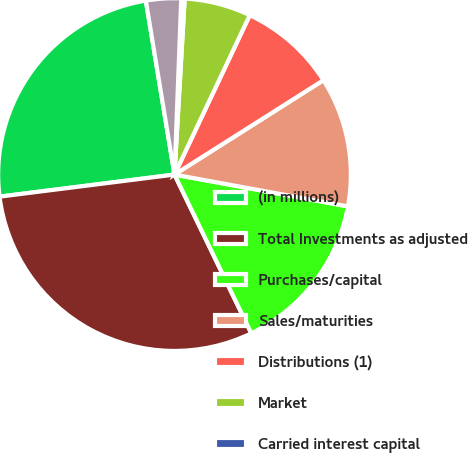<chart> <loc_0><loc_0><loc_500><loc_500><pie_chart><fcel>(in millions)<fcel>Total Investments as adjusted<fcel>Purchases/capital<fcel>Sales/maturities<fcel>Distributions (1)<fcel>Market<fcel>Carried interest capital<fcel>Other<nl><fcel>24.4%<fcel>30.18%<fcel>14.94%<fcel>11.88%<fcel>8.99%<fcel>6.1%<fcel>0.31%<fcel>3.21%<nl></chart> 